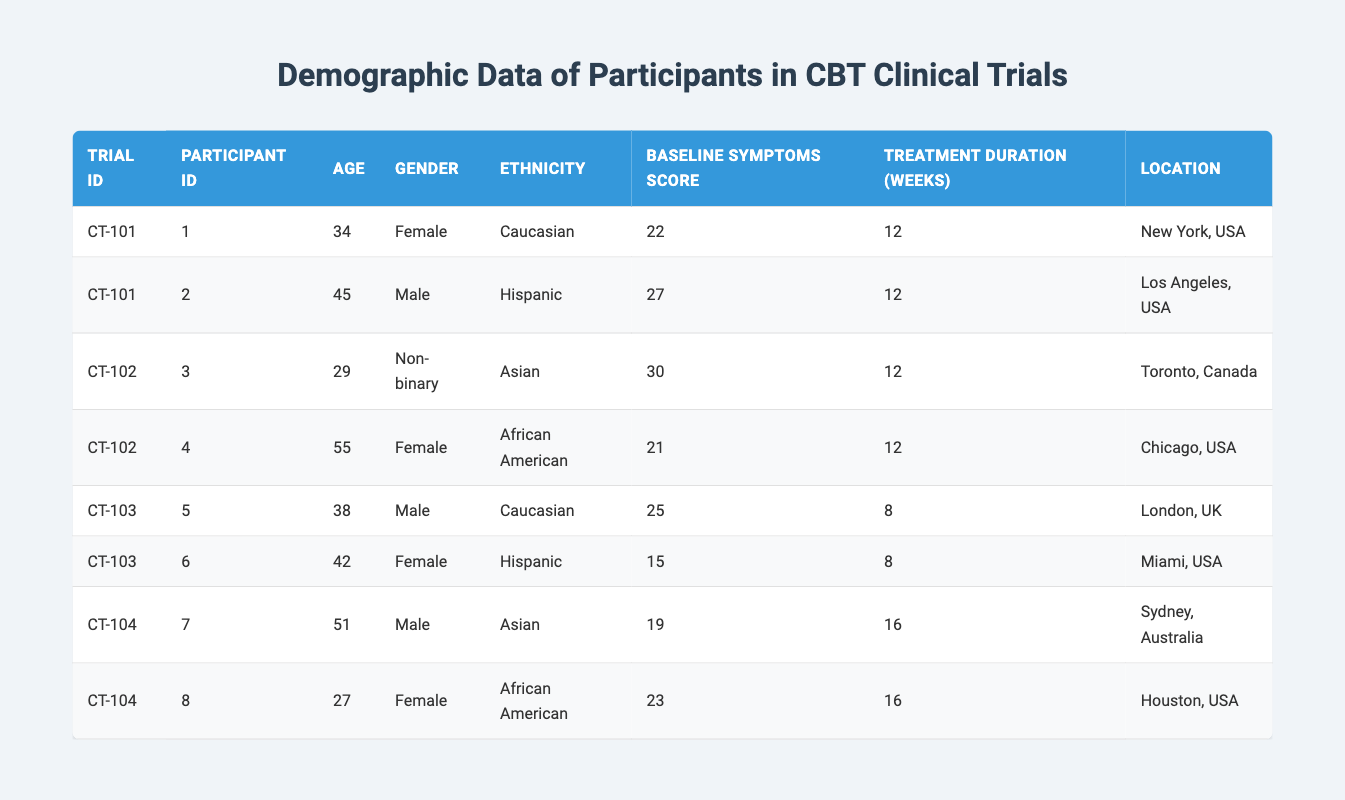What is the age of the youngest participant in the trials? The youngest participant is from trial CT-104 with participant ID 8, who is 27 years old.
Answer: 27 How many participants are Female? By referring to the gender column, participants with IDs 1, 4, 6, and 8 are identified as Female, making a total of 4 Female participants.
Answer: 4 What is the baseline symptoms score of the oldest participant? The oldest participant is from trial CT-102 with participant ID 4, aged 55, and their baseline symptoms score is 21.
Answer: 21 What is the average baseline symptoms score for participants in trial CT-101? The baseline symptoms scores for trial CT-101 are 22 and 27. The sum is 49 and there are 2 participants, so the average is 49/2 = 24.5.
Answer: 24.5 Are there any Non-binary participants in the trials? Yes, there is one Non-binary participant from trial CT-102 with participant ID 3.
Answer: Yes What is the total treatment duration in weeks for all participants in CT-104? From trial CT-104, participants 7 and 8 have treatment durations of 16 weeks each. The total is 16 + 16 = 32 weeks.
Answer: 32 Which location has the oldest participant among all trials? The oldest participant is from Chicago, USA, with participant ID 4 aged 55. Comparing locations, Chicago has the oldest participant.
Answer: Chicago How many participants scored below 20 on their baseline symptoms score? Participants from trials CT-103 and CT-104 scored below 20: participant 6 scored 15 and participant 7 scored 19. This makes a total of 2 participants scoring below 20.
Answer: 2 